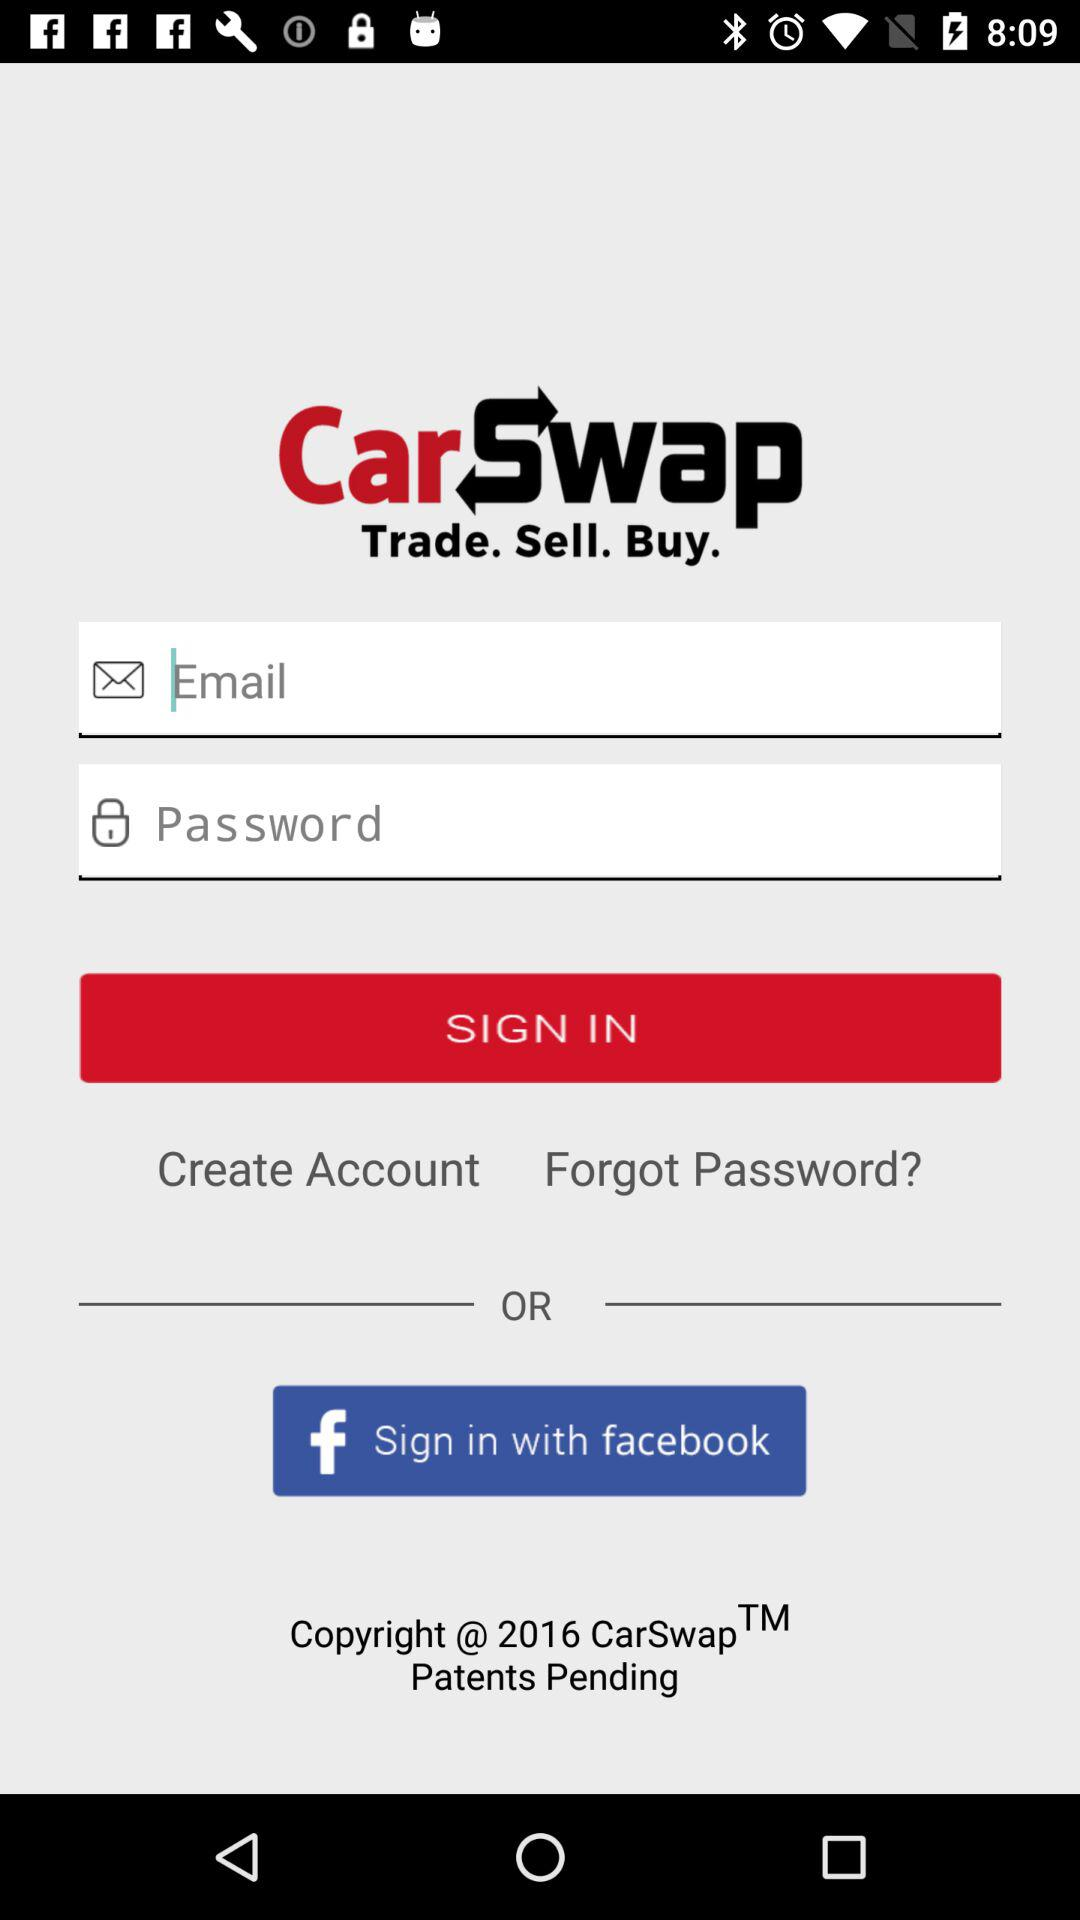What is the application name? The application name is "CarSwap". 